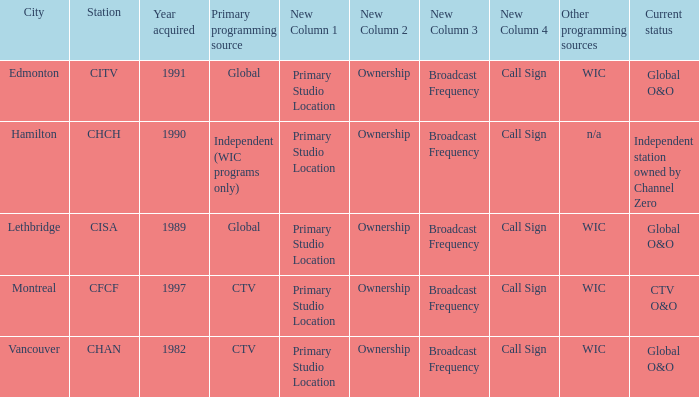How any were gained as the chan 1.0. 